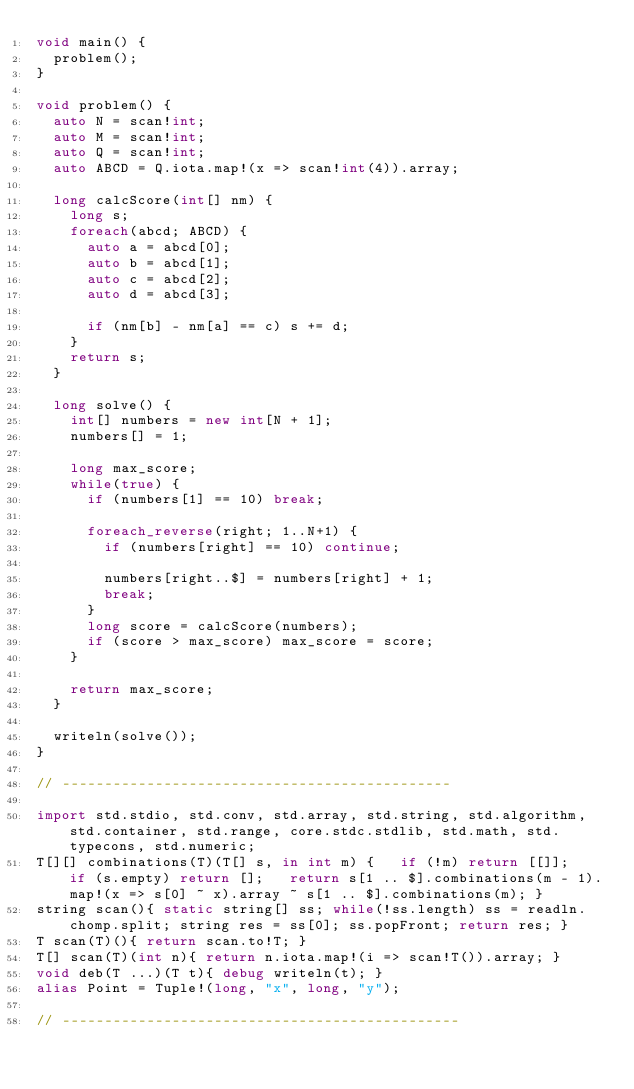<code> <loc_0><loc_0><loc_500><loc_500><_D_>void main() {
  problem();
}

void problem() {
  auto N = scan!int;
  auto M = scan!int;
  auto Q = scan!int;
  auto ABCD = Q.iota.map!(x => scan!int(4)).array;

  long calcScore(int[] nm) {
    long s;
    foreach(abcd; ABCD) {
      auto a = abcd[0];
      auto b = abcd[1];
      auto c = abcd[2];
      auto d = abcd[3];

      if (nm[b] - nm[a] == c) s += d;
    }
    return s;
  }

  long solve() {
    int[] numbers = new int[N + 1];
    numbers[] = 1;

    long max_score;
    while(true) {
      if (numbers[1] == 10) break;

      foreach_reverse(right; 1..N+1) {
        if (numbers[right] == 10) continue;

        numbers[right..$] = numbers[right] + 1;
        break;
      }
      long score = calcScore(numbers);
      if (score > max_score) max_score = score;
    }

    return max_score;
  }

  writeln(solve());
}

// ----------------------------------------------

import std.stdio, std.conv, std.array, std.string, std.algorithm, std.container, std.range, core.stdc.stdlib, std.math, std.typecons, std.numeric;
T[][] combinations(T)(T[] s, in int m) {   if (!m) return [[]];   if (s.empty) return [];   return s[1 .. $].combinations(m - 1).map!(x => s[0] ~ x).array ~ s[1 .. $].combinations(m); }
string scan(){ static string[] ss; while(!ss.length) ss = readln.chomp.split; string res = ss[0]; ss.popFront; return res; }
T scan(T)(){ return scan.to!T; }
T[] scan(T)(int n){ return n.iota.map!(i => scan!T()).array; }
void deb(T ...)(T t){ debug writeln(t); }
alias Point = Tuple!(long, "x", long, "y");

// -----------------------------------------------
</code> 